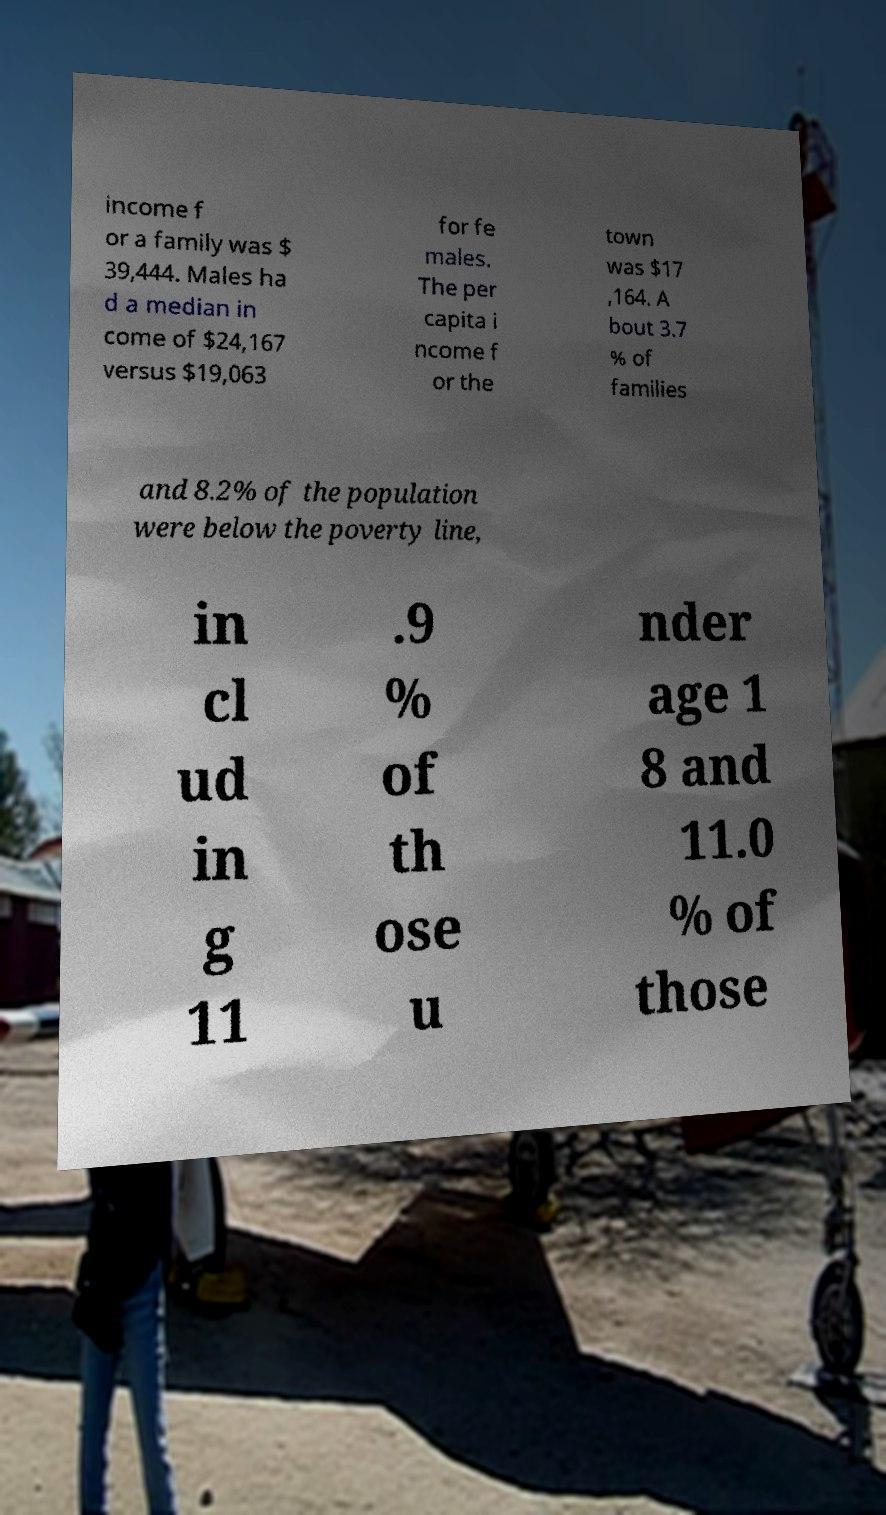There's text embedded in this image that I need extracted. Can you transcribe it verbatim? income f or a family was $ 39,444. Males ha d a median in come of $24,167 versus $19,063 for fe males. The per capita i ncome f or the town was $17 ,164. A bout 3.7 % of families and 8.2% of the population were below the poverty line, in cl ud in g 11 .9 % of th ose u nder age 1 8 and 11.0 % of those 